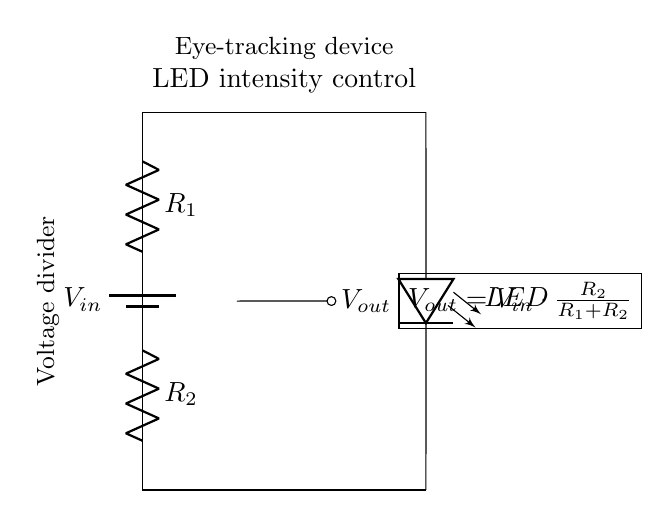What are the two resistors in the circuit? The circuit contains two resistors labeled as R1 and R2, which are part of the voltage divider configuration.
Answer: R1 and R2 What is the purpose of the LED in this circuit? The LED is used to visually indicate the intensity of light, controlled by the voltage divider, which adjusts its brightness based on the output voltage.
Answer: Indicator What is the formula for the output voltage? The output voltage, Vout, is calculated using the formula Vout = Vin * (R2 / (R1 + R2)), which defines how the voltage is divided between the two resistors.
Answer: Vout = Vin * (R2 / (R1 + R2)) Which component controls the LED intensity? The intensity of the LED is controlled by the voltage divider formed by the resistors R1 and R2, which determines the output voltage that powers the LED.
Answer: Voltage divider If R1 is twice the value of R2, how does that affect Vout? If R1 is twice the value of R2, the output voltage Vout will be one-third of the input voltage Vin, as the division of voltage depends on the ratio of the resistors.
Answer: One-third of Vin What happens if R2 is removed from the circuit? If R2 is removed, the entire input voltage Vin would appear across R1, resulting in no voltage drop to control the LED, which would either be off or only respond to R1, altering functionality.
Answer: LED off What type of circuit configuration is used in this diagram? The circuit exemplifies a voltage divider configuration, where two resistors are arranged in series to divide the input voltage and produce an output voltage for the LED.
Answer: Voltage divider 